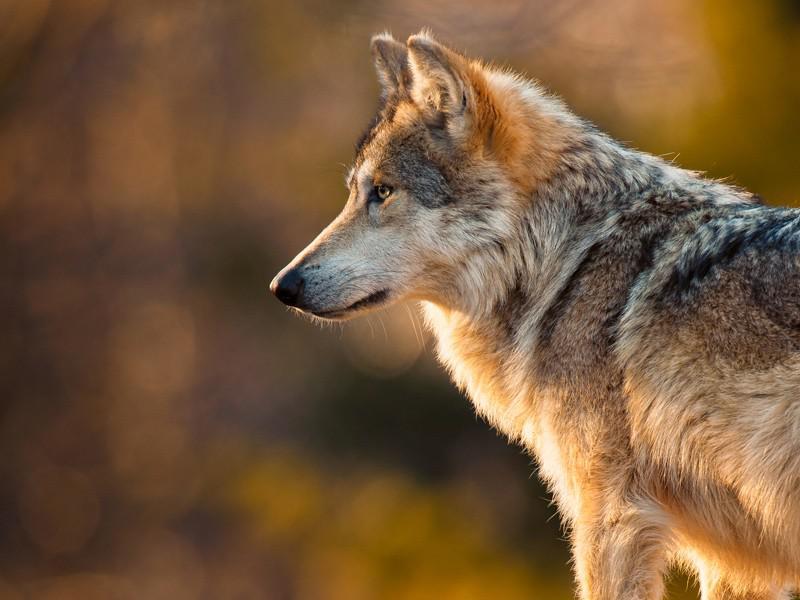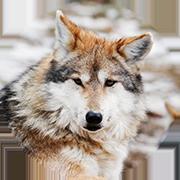The first image is the image on the left, the second image is the image on the right. Examine the images to the left and right. Is the description "The wolf in one of the images is standing in the green grass." accurate? Answer yes or no. No. The first image is the image on the left, the second image is the image on the right. Evaluate the accuracy of this statement regarding the images: "One image shows a leftward-facing wolf standing in a green grassy area.". Is it true? Answer yes or no. No. 